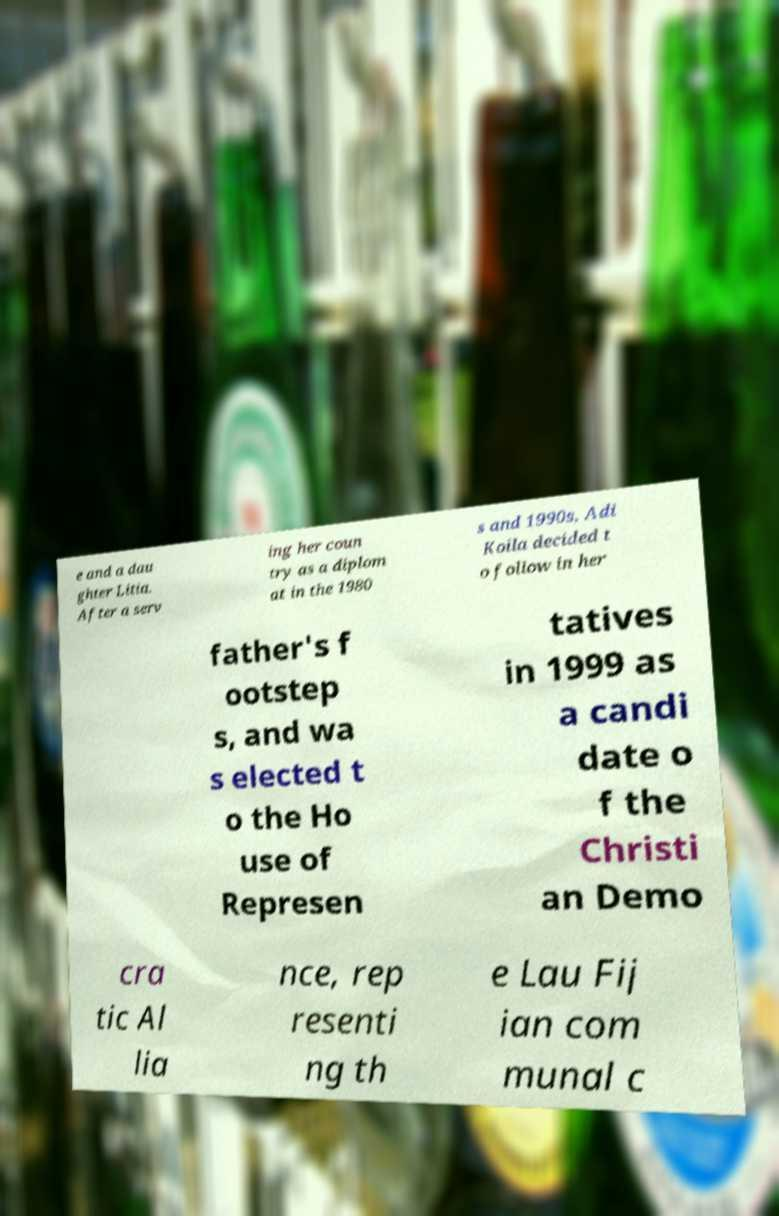I need the written content from this picture converted into text. Can you do that? e and a dau ghter Litia. After a serv ing her coun try as a diplom at in the 1980 s and 1990s, Adi Koila decided t o follow in her father's f ootstep s, and wa s elected t o the Ho use of Represen tatives in 1999 as a candi date o f the Christi an Demo cra tic Al lia nce, rep resenti ng th e Lau Fij ian com munal c 